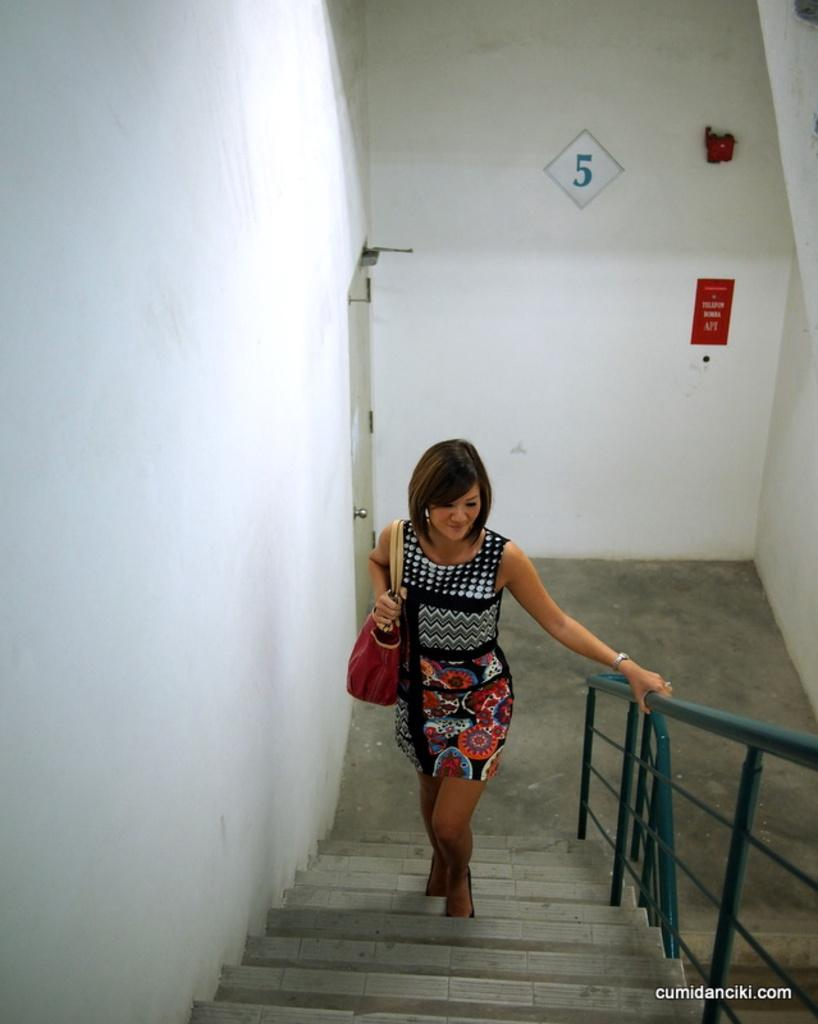Who is the main subject in the image? There is a woman in the image. What is the woman doing in the image? The woman is climbing stairs. What is the woman holding in the image? The woman is holding a handbag. What can be seen on the wall in the image? There is a poster on the wall in the image. What numerical information is visible in the image? There is a number visible in the image. What text is present in the bottom right corner of the image? There is text in the bottom right corner of the image. What channel is the woman watching on the television in the image? There is no television present in the image, so it is not possible to determine what channel the woman might be watching. 